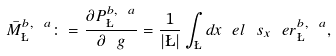<formula> <loc_0><loc_0><loc_500><loc_500>\bar { M } ^ { b , \ a } _ { \L } \colon = \frac { \partial P ^ { b , \ a } _ { \L } } { \partial \ g } = \frac { 1 } { | \L | } \int _ { \L } d x \ e l \ s _ { x } \ e r ^ { b , \ a } _ { \L } ,</formula> 